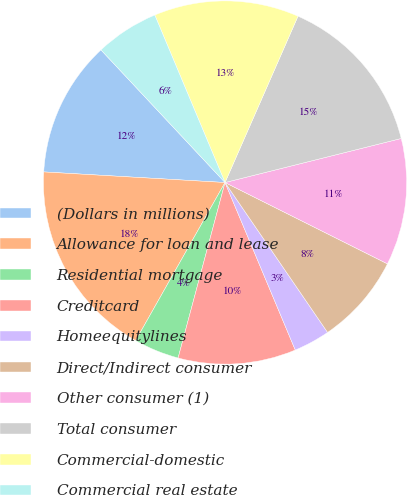Convert chart to OTSL. <chart><loc_0><loc_0><loc_500><loc_500><pie_chart><fcel>(Dollars in millions)<fcel>Allowance for loan and lease<fcel>Residential mortgage<fcel>Creditcard<fcel>Homeequitylines<fcel>Direct/Indirect consumer<fcel>Other consumer (1)<fcel>Total consumer<fcel>Commercial-domestic<fcel>Commercial real estate<nl><fcel>12.1%<fcel>17.74%<fcel>4.03%<fcel>10.48%<fcel>3.23%<fcel>8.06%<fcel>11.29%<fcel>14.52%<fcel>12.9%<fcel>5.65%<nl></chart> 